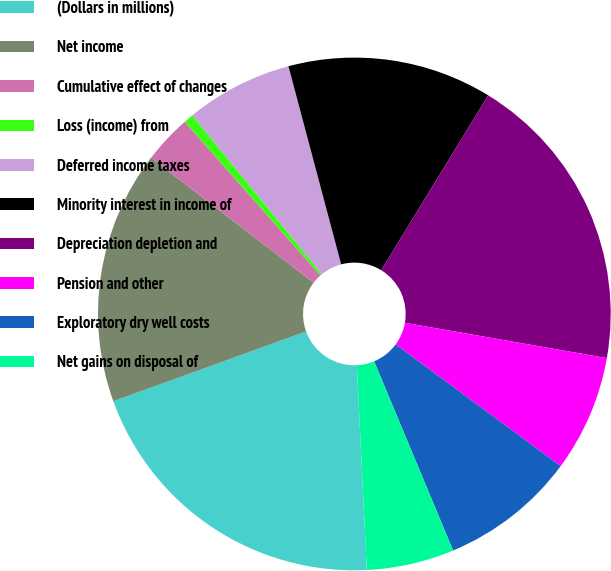Convert chart to OTSL. <chart><loc_0><loc_0><loc_500><loc_500><pie_chart><fcel>(Dollars in millions)<fcel>Net income<fcel>Cumulative effect of changes<fcel>Loss (income) from<fcel>Deferred income taxes<fcel>Minority interest in income of<fcel>Depreciation depletion and<fcel>Pension and other<fcel>Exploratory dry well costs<fcel>Net gains on disposal of<nl><fcel>20.24%<fcel>15.95%<fcel>3.07%<fcel>0.62%<fcel>6.75%<fcel>12.88%<fcel>19.01%<fcel>7.36%<fcel>8.59%<fcel>5.52%<nl></chart> 